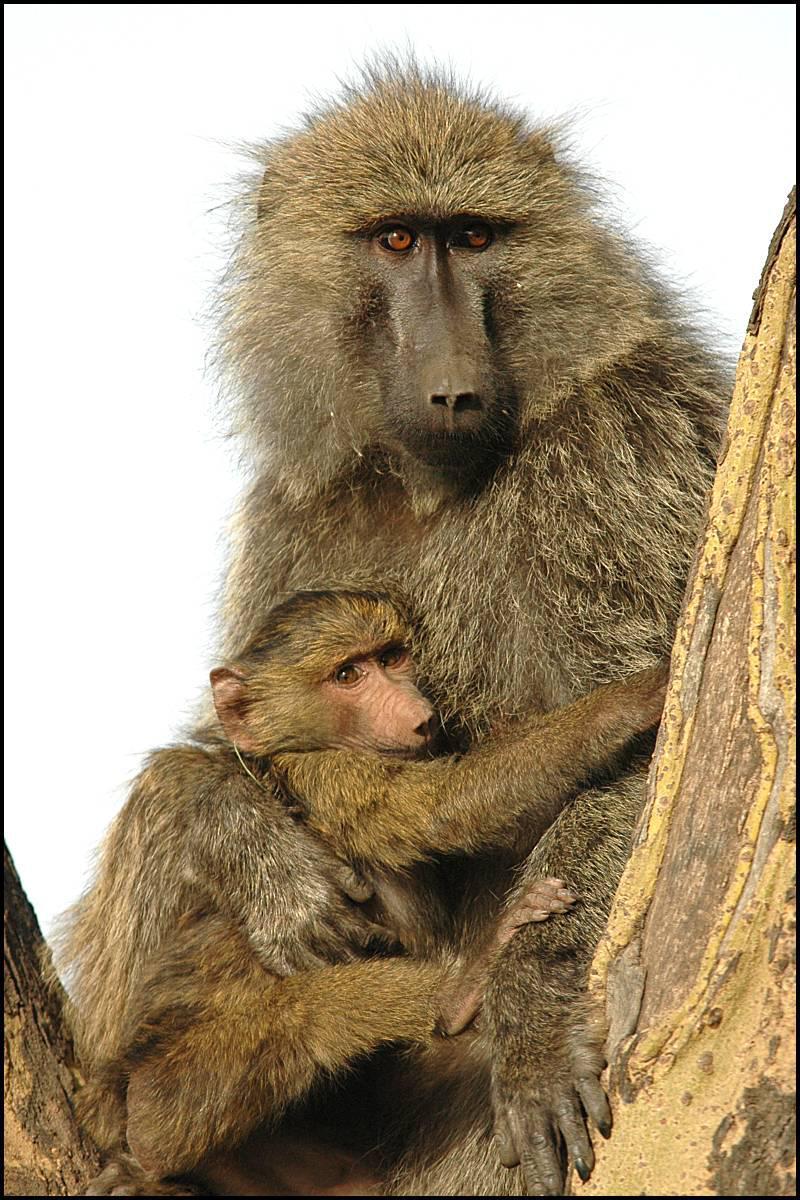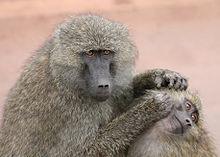The first image is the image on the left, the second image is the image on the right. Considering the images on both sides, is "Each image shows two animals interacting, and one image shows a monkey grooming the animal next to it." valid? Answer yes or no. Yes. The first image is the image on the left, the second image is the image on the right. Assess this claim about the two images: "There are exactly three apes.". Correct or not? Answer yes or no. No. 